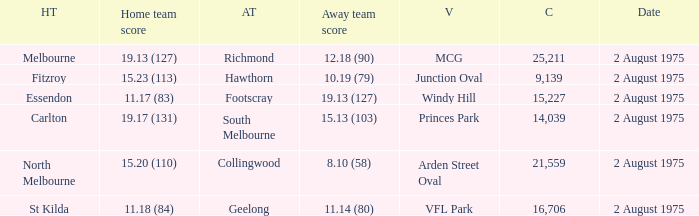Where did the home team score 11.18 (84)? VFL Park. 